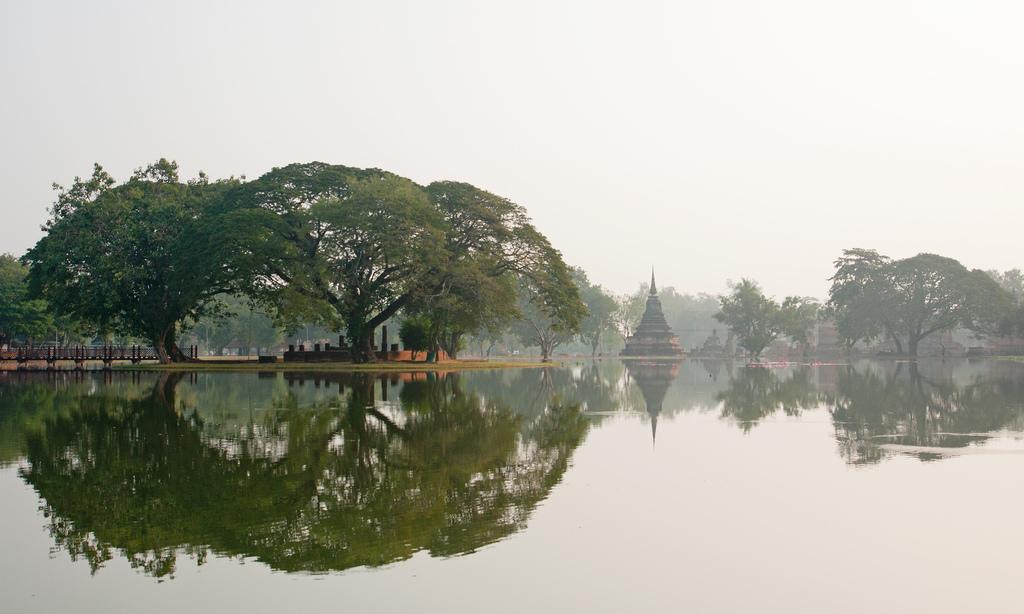Could you give a brief overview of what you see in this image? In this picture we can see there are trees and some architectures. Behind the trees there is the sky. In front of the trees, it looks like a lake. 